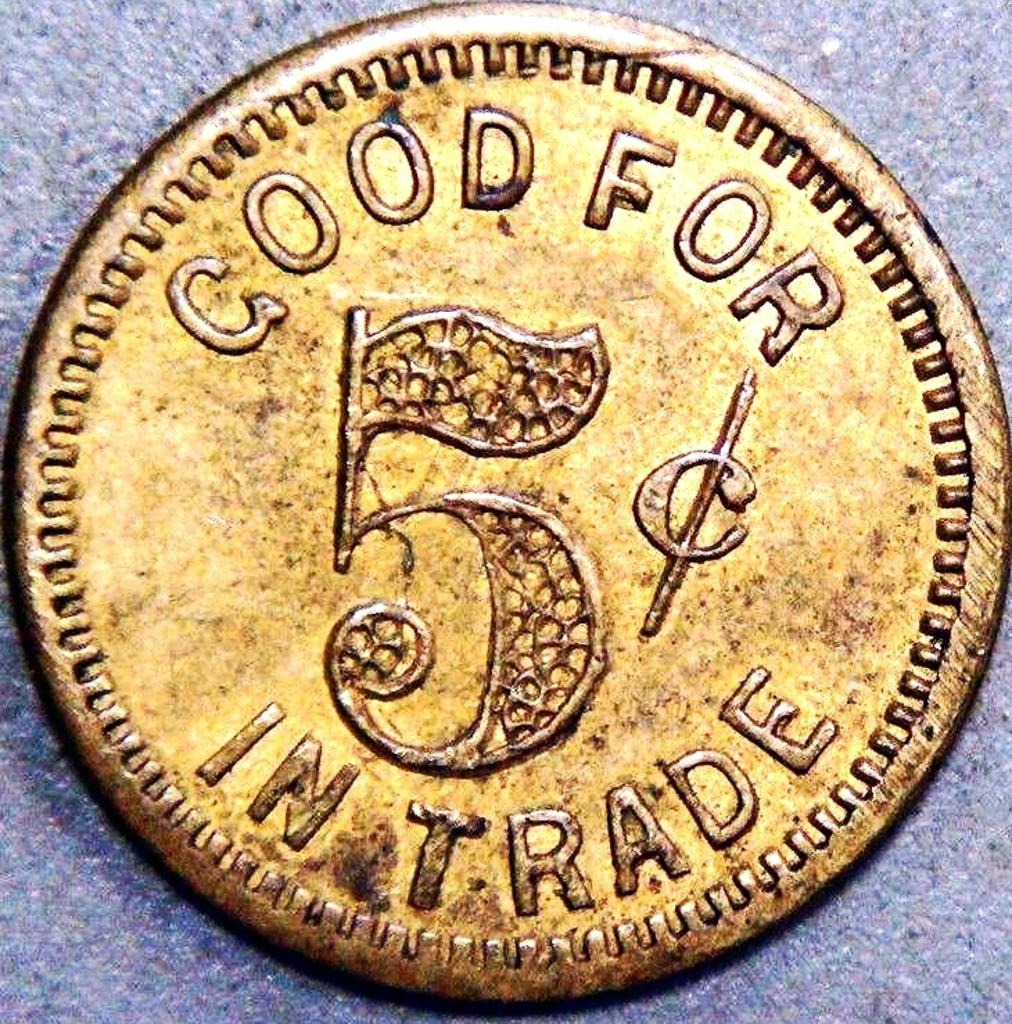What object is the main focus of the image? There is a coin in the image. Where is the zebra located in the image? There is no zebra present in the image; it only features a coin. What type of glue is being used to stick the coin to the surface in the image? There is no glue or indication of adhesion in the image; it only shows a coin. 